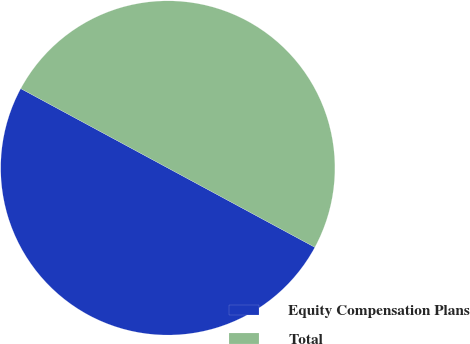Convert chart. <chart><loc_0><loc_0><loc_500><loc_500><pie_chart><fcel>Equity Compensation Plans<fcel>Total<nl><fcel>50.0%<fcel>50.0%<nl></chart> 